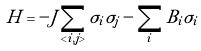<formula> <loc_0><loc_0><loc_500><loc_500>H = - J \sum _ { < i , j > } \sigma _ { i } \sigma _ { j } - \sum _ { i } B _ { i } \sigma _ { i }</formula> 